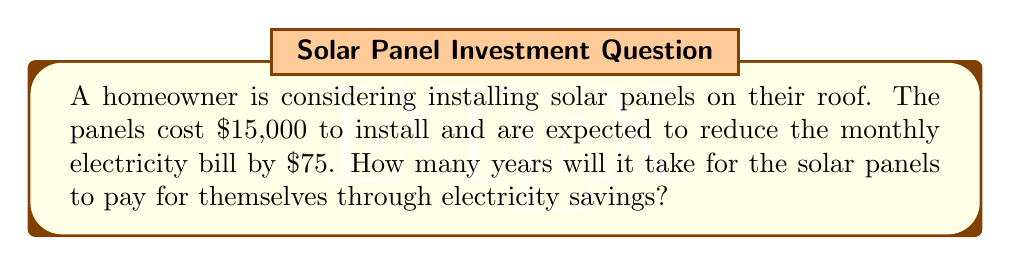Give your solution to this math problem. Let's approach this problem step-by-step:

1. First, we need to calculate the annual savings on electricity:
   Monthly savings = $75
   Annual savings = $75 × 12 months = $900 per year

2. Now, we need to find out how long it will take for these savings to equal the initial cost of the solar panels:
   Let $x$ be the number of years it takes to break even.

3. We can set up an equation:
   Total savings over $x$ years = Cost of installation
   $900x = 15000$

4. To solve for $x$, we divide both sides by 900:
   $x = \frac{15000}{900} = 16.67$ years

5. Since we're dealing with whole years, we need to round up to the nearest year:
   $x \approx 17$ years

Therefore, it will take 17 years for the solar panels to pay for themselves through electricity savings.
Answer: 17 years 